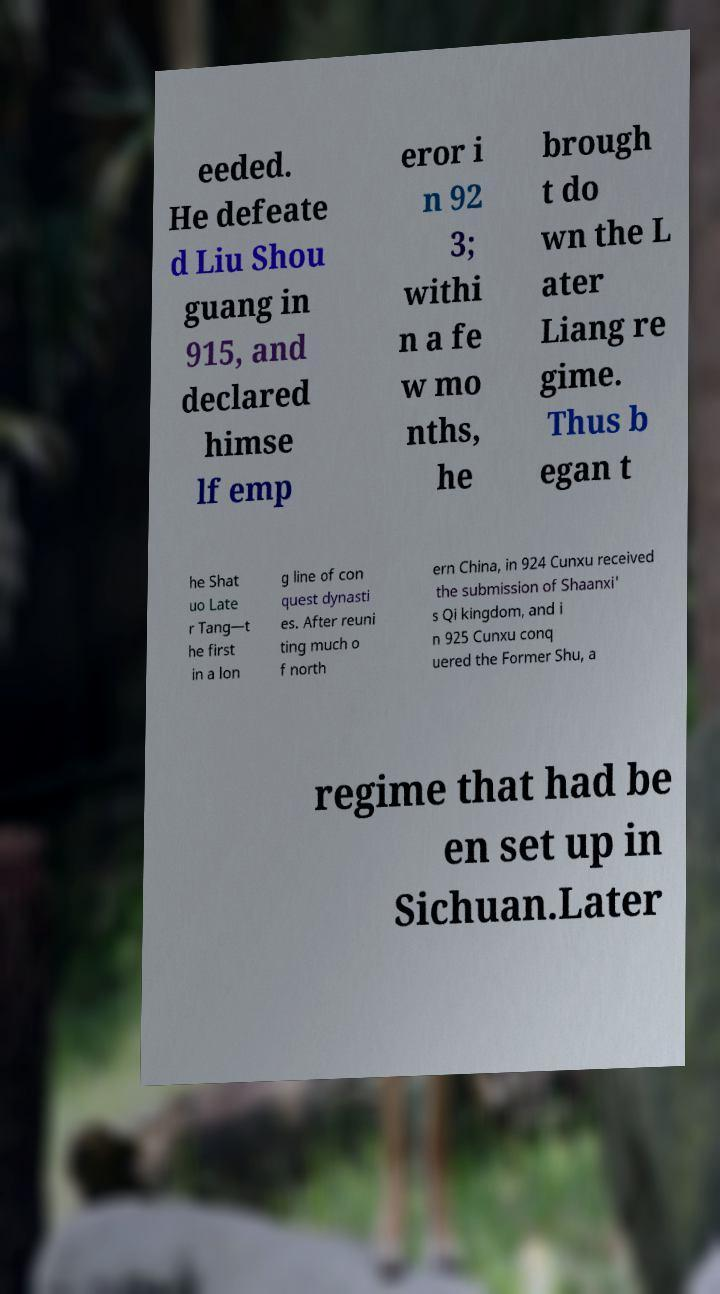For documentation purposes, I need the text within this image transcribed. Could you provide that? eeded. He defeate d Liu Shou guang in 915, and declared himse lf emp eror i n 92 3; withi n a fe w mo nths, he brough t do wn the L ater Liang re gime. Thus b egan t he Shat uo Late r Tang—t he first in a lon g line of con quest dynasti es. After reuni ting much o f north ern China, in 924 Cunxu received the submission of Shaanxi' s Qi kingdom, and i n 925 Cunxu conq uered the Former Shu, a regime that had be en set up in Sichuan.Later 